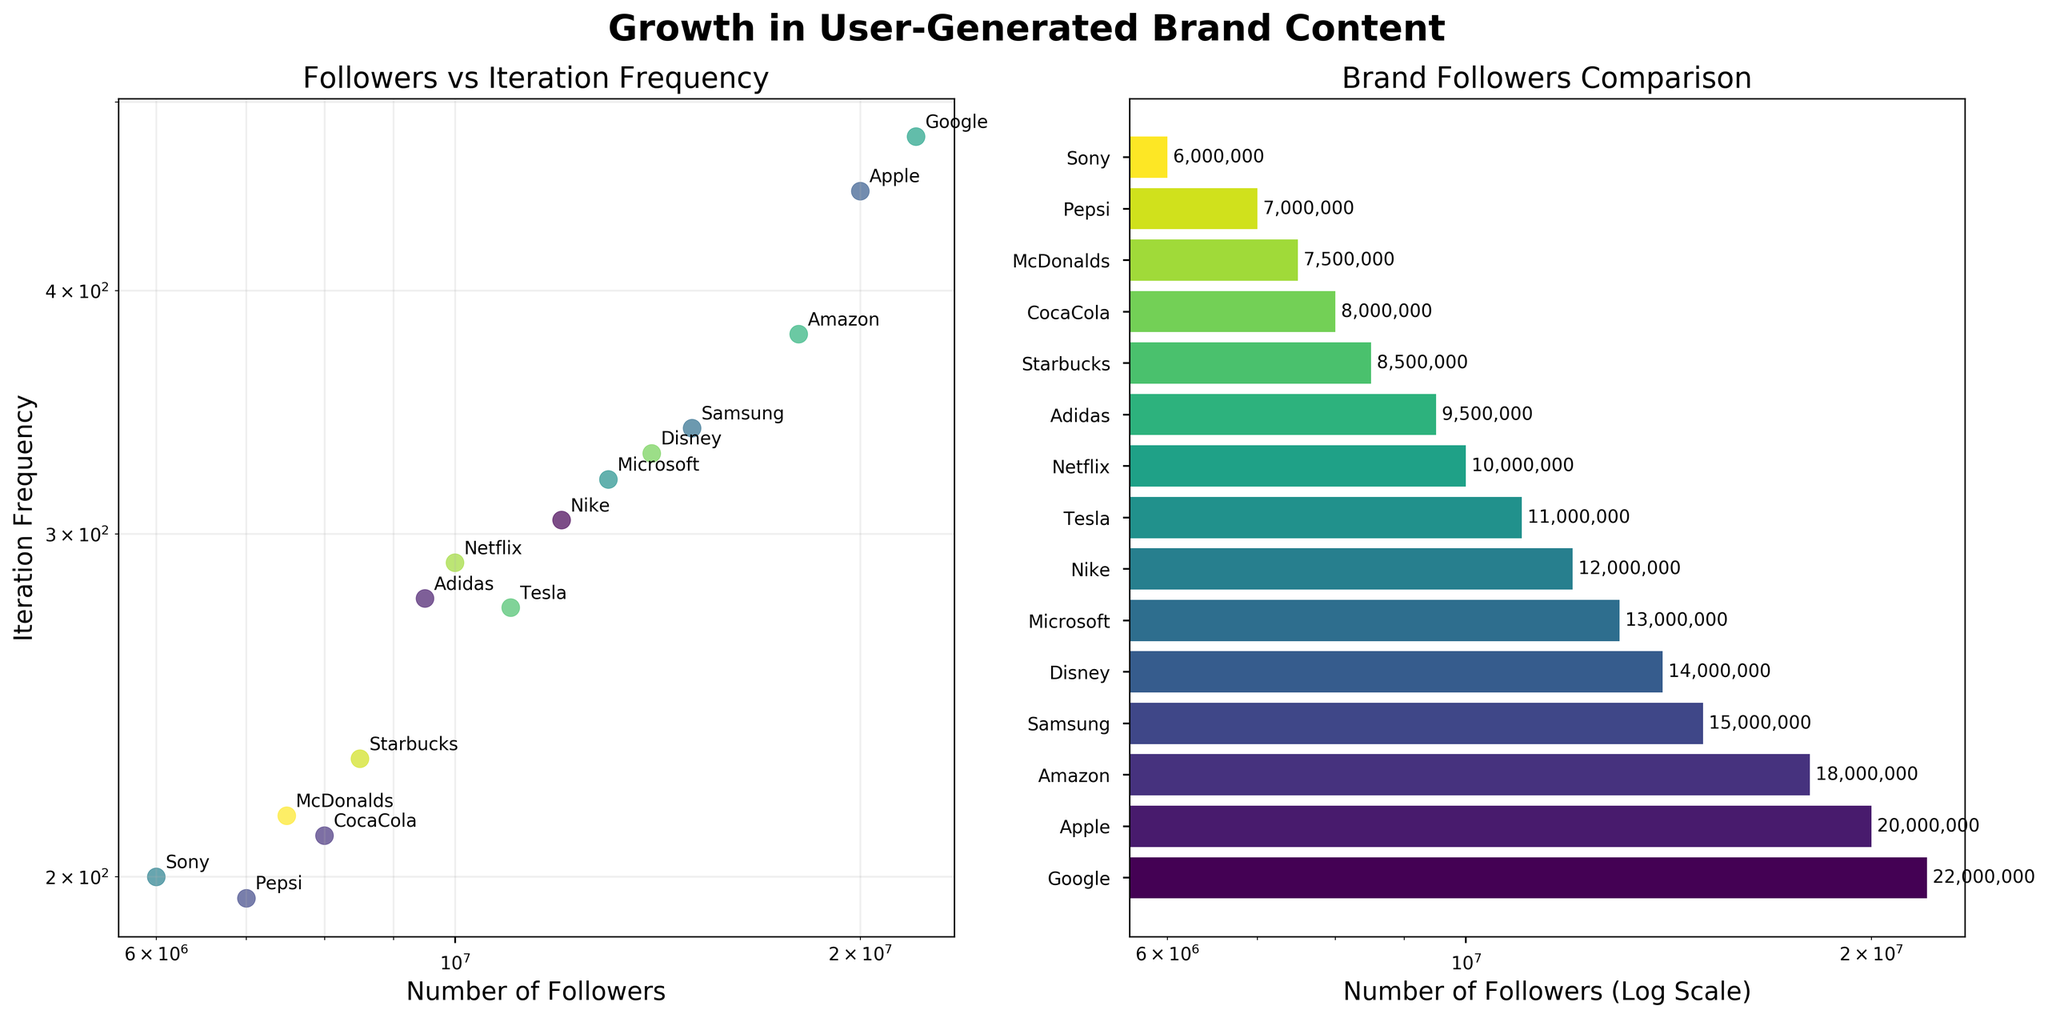Which brand has the highest number of followers? Refer to the horizontal bar chart on the right. The brand with the highest bar represents the highest number of followers. According to the bar chart, Google has the highest number of followers.
Answer: Google What is the main takeaway from the scatter plot about the relationship between the number of followers and iteration frequency? By examining the scatter plot on the left, observe that points generally trend upwards from left to right, indicating a positive relationship. As the number of followers increases, the iteration frequency also tends to increase.
Answer: There is a positive relationship Which two brands have the closest iteration frequencies despite having different follower counts? Observe the scatter plot and check for points that are vertically close. Nike and Disney have very similar iteration frequencies but different follower counts.
Answer: Nike and Disney How is the data represented on the X and Y axes in both subplots? The scatter plot uses a logarithmic scale for both axes, while the bar chart uses a logarithmic scale for the X-axis only. Notice the "log" labels on the axes and the tick marks showing exponential growth.
Answer: Both subplots use logarithmic scales, but the scatter plot uses it for both axes while the bar chart uses it for the X-axis If Samsung's followers double, what will be its new followers count? Samsung's initial followers from the data is 15,000,000. Doubling this value gives 30,000,000.
Answer: 30,000,000 Which brand shows the highest iteration frequency, and how does its follower count compare to others? Look at the scatter plot for the highest vertical point. Google has the highest iteration frequency. Comparing it to the bar chart on the right, Google also has the highest follower count, showing it leads in both metrics.
Answer: Google; It has the highest number of followers What is the relationship between Apple's followers and iteration frequency compared to that of Starbucks? Using the scatter plot, compare the positions of Apple and Starbucks. Apple has a higher number of followers and a higher iteration frequency than Starbucks.
Answer: Apple has both higher followers and iteration frequency than Starbucks How does Amazon's follower count compare with Nike's follower count? Refer to the bar chart on the right. Amazon's bar is longer than Nike's, indicating Amazon has more followers.
Answer: Amazon has more followers than Nike Identify brands with follower counts close to the median value. The median number of followers can be approximated by looking at the middle bar in the sorted bar chart. Starbucks and McDonalds are close to the center and have follower counts near the median.
Answer: Starbucks and McDonalds 